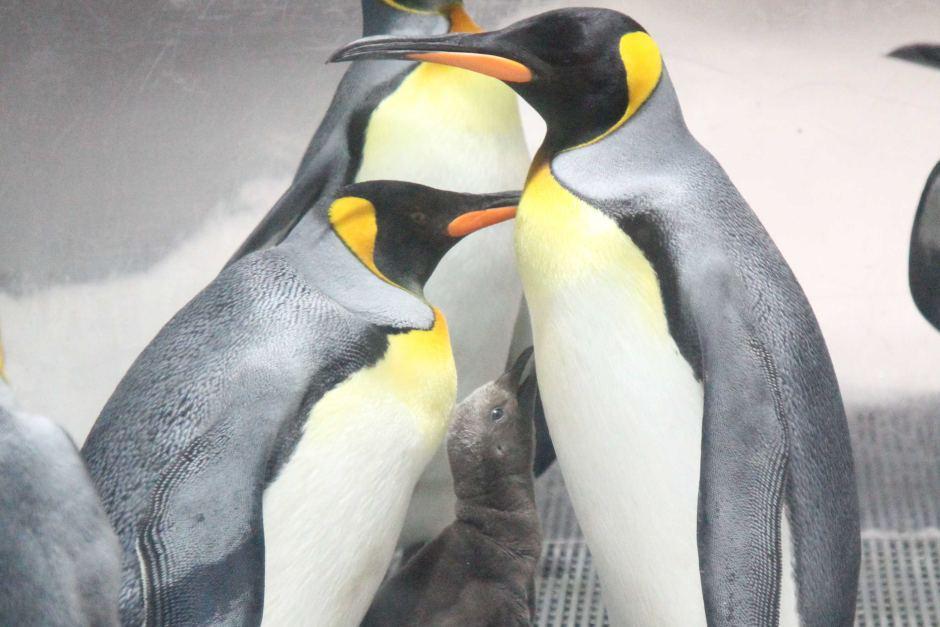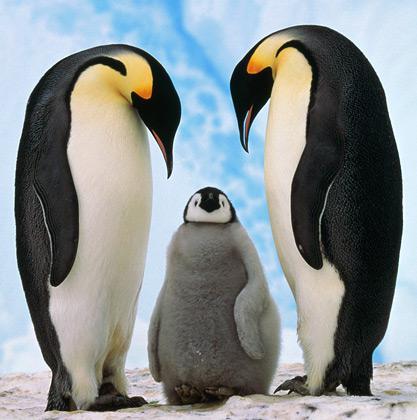The first image is the image on the left, the second image is the image on the right. For the images shown, is this caption "We can see exactly two baby penguins." true? Answer yes or no. Yes. The first image is the image on the left, the second image is the image on the right. For the images shown, is this caption "Both photos in the pair have adult penguins and young penguins." true? Answer yes or no. Yes. 